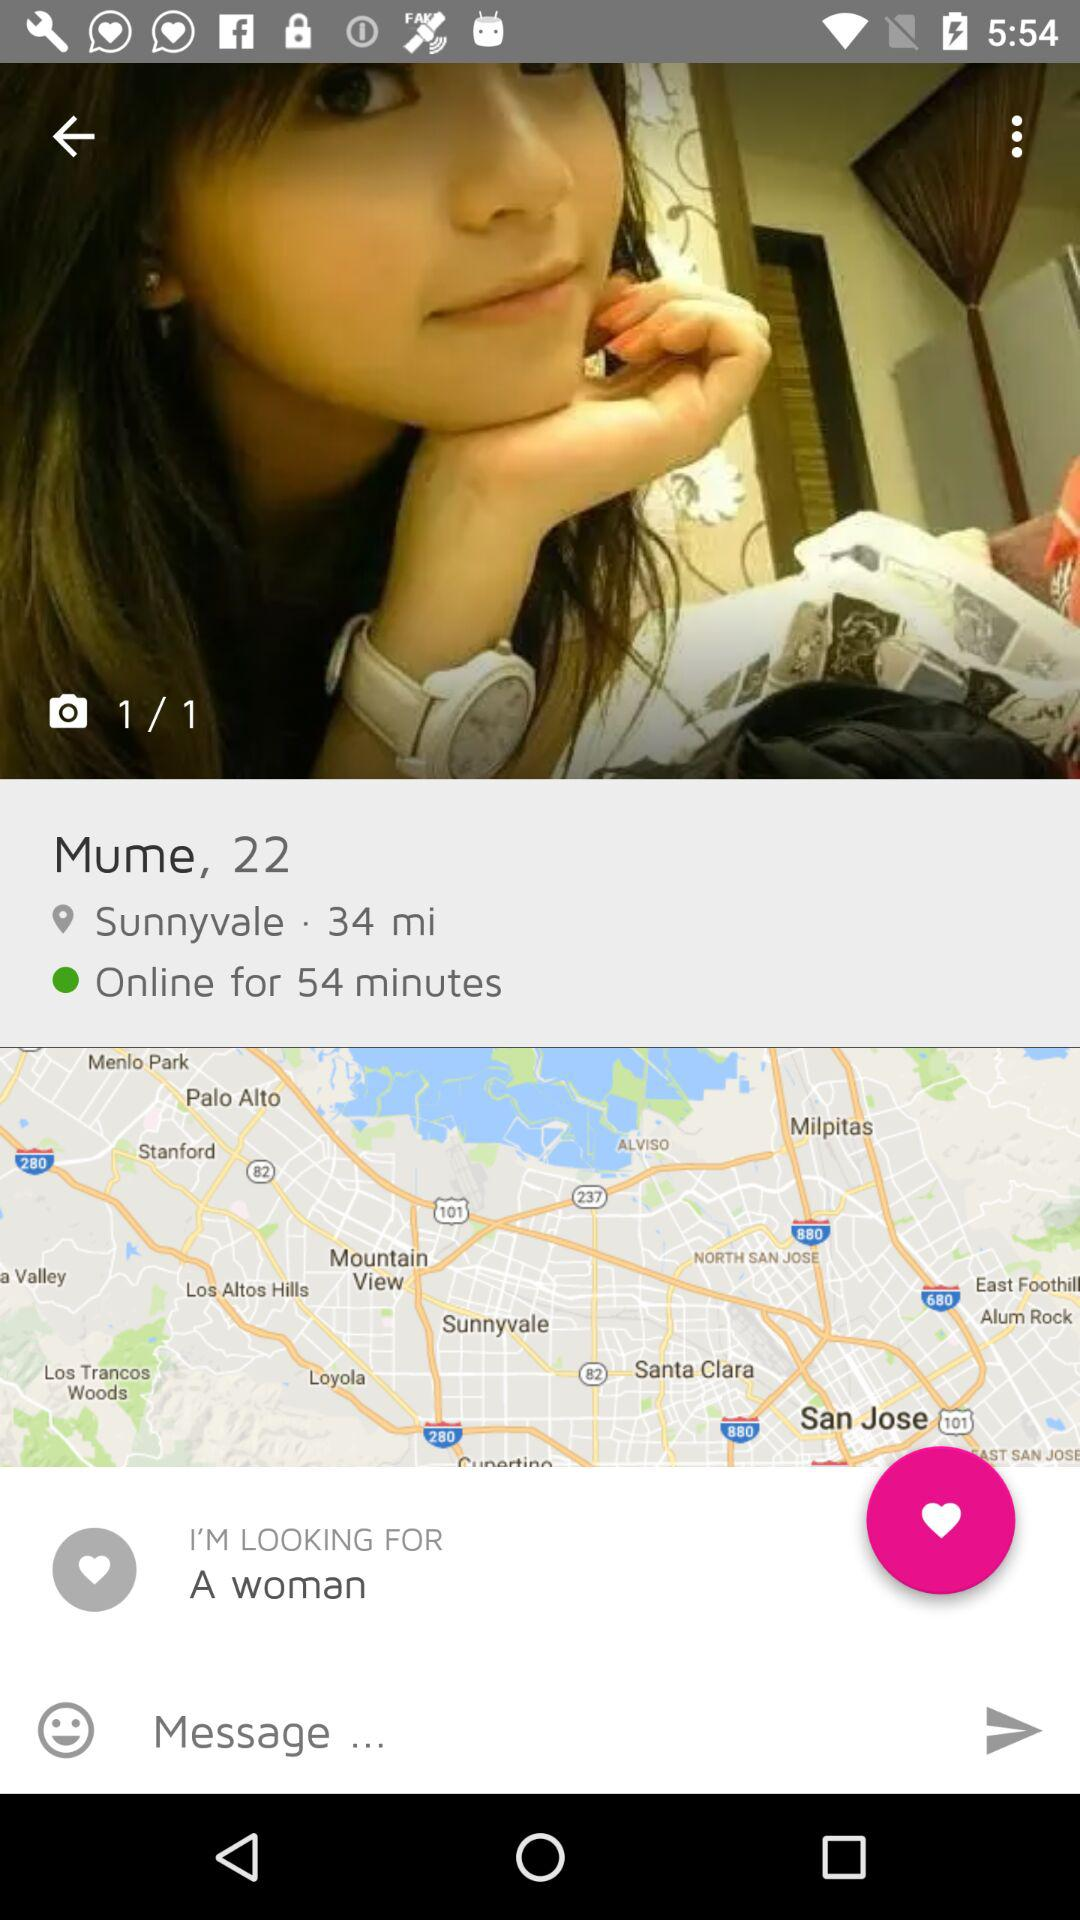What is the age of the user? The age of the user is 22 years. 